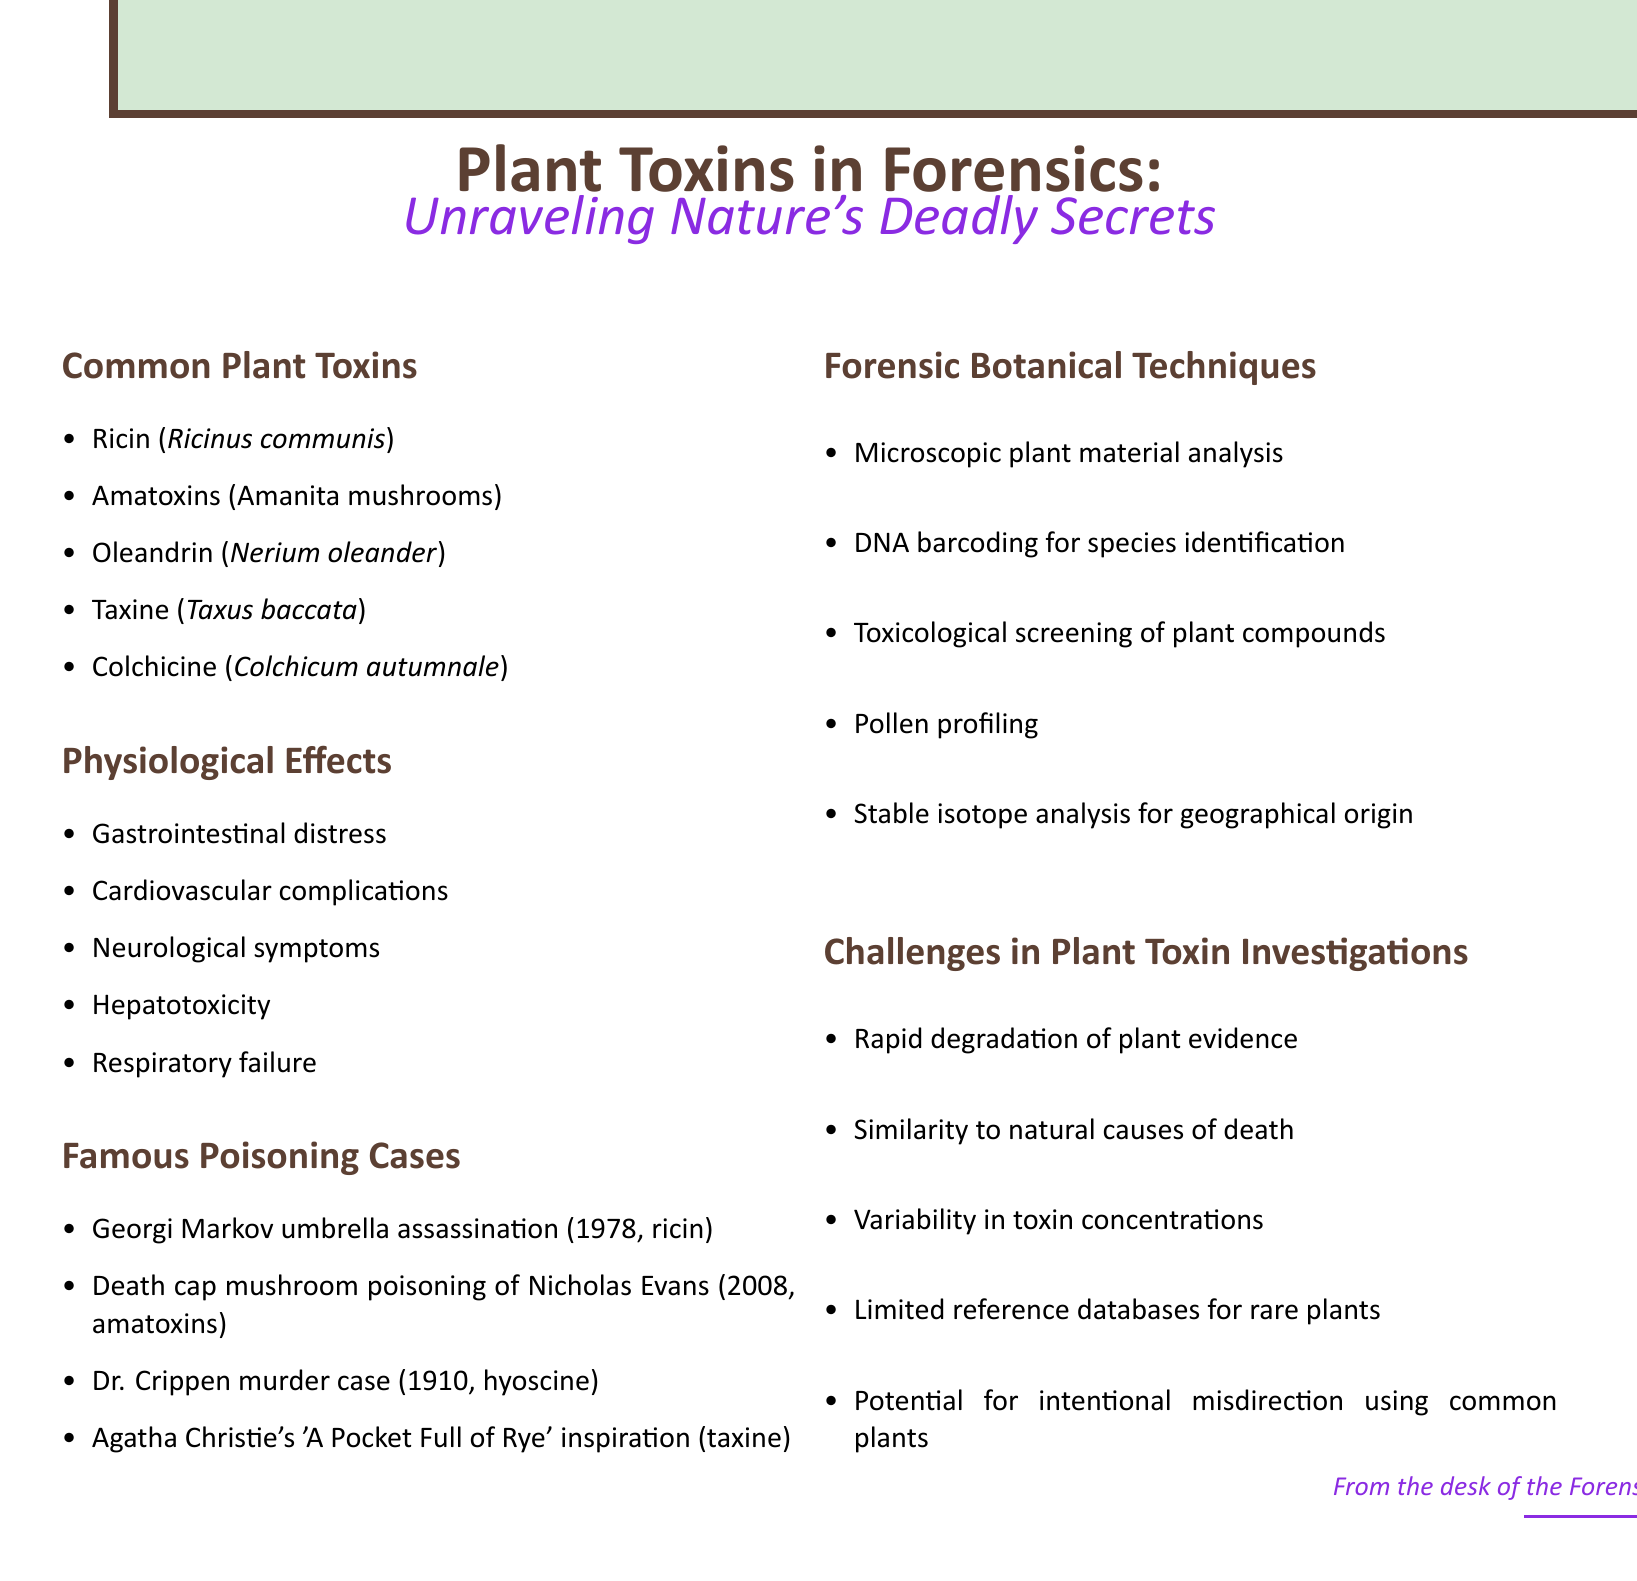What is the first common plant toxin listed? The document lists Ricin as the first common plant toxin under the section titled "Common Plant Toxins."
Answer: Ricin How many physiological effects are mentioned? The document includes five physiological effects under the section titled "Physiological Effects."
Answer: Five What is one case associated with amatoxins? The case of Nicholas Evans is mentioned in relation to amatoxins under "Famous Poisoning Cases."
Answer: Death cap mushroom poisoning of Nicholas Evans Which forensic technique is used for species identification? DNA barcoding is specified in the section "Forensic Botanical Techniques" as a method for species identification.
Answer: DNA barcoding What is a challenge mentioned in plant toxin investigations? One of the challenges listed is the rapid degradation of plant evidence in the section titled "Challenges in Plant Toxin Investigations."
Answer: Rapid degradation of plant evidence What type of document is this? The document is a catalog focusing on plant toxins and their forensic implications.
Answer: Catalog 